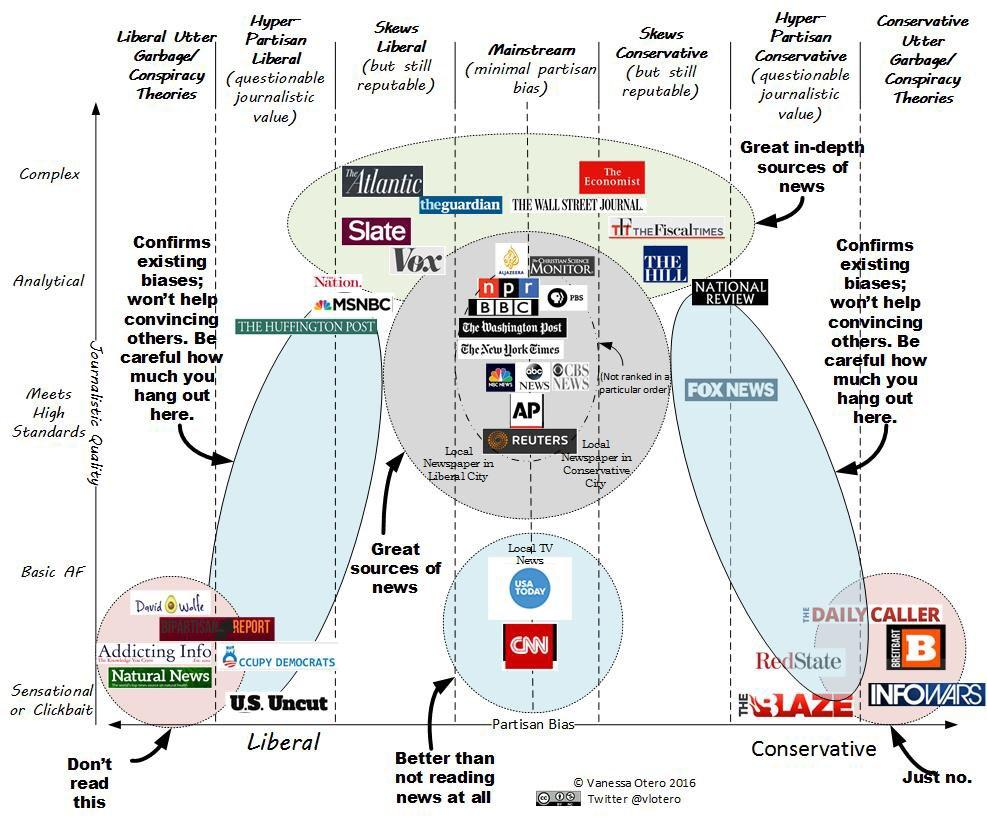Indicate a few pertinent items in this graphic. Infowars is the lowest quality, extreme conservative, and biased journal. The hyper-partisan liberal category of US Uncut has the lowest quality. How many sections are journals divided into based on partisan bias in this infographic? The answer is 7. Natural News is the lowest quality, extreme liberal biased journal. The category of BBC and Reuters is considered to be mainstream. 